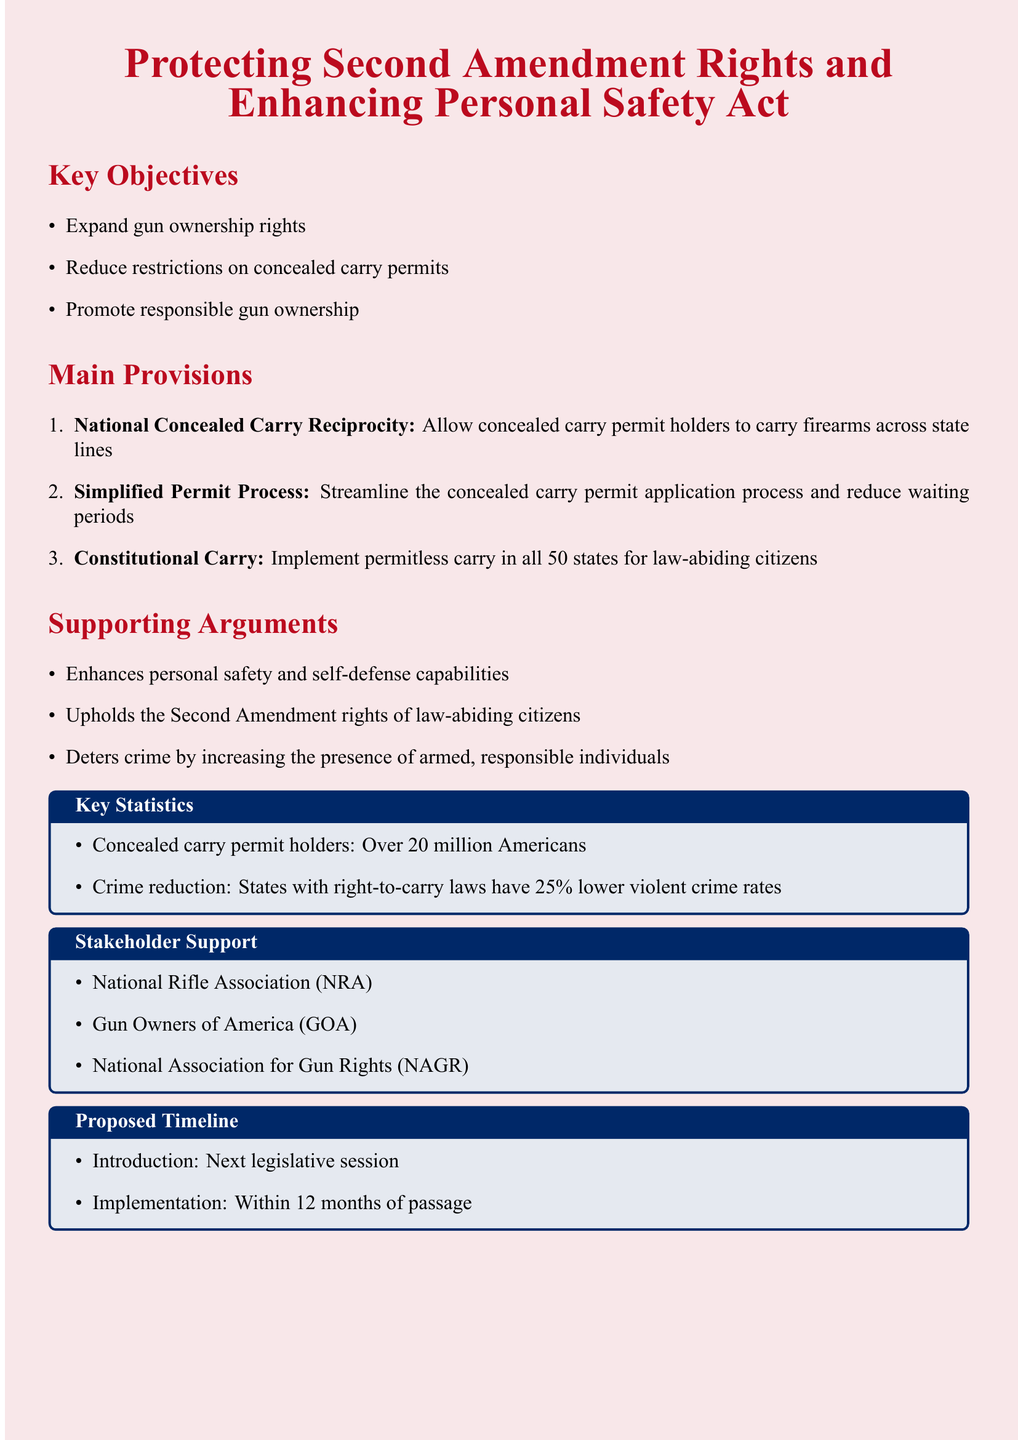What is the title of the legislation? The title of the legislation is found at the beginning of the document and is stated as "Protecting Second Amendment Rights and Enhancing Personal Safety Act."
Answer: Protecting Second Amendment Rights and Enhancing Personal Safety Act How many objectives are listed in the document? The document lists three key objectives related to gun ownership and concealed carry permits.
Answer: 3 Which organization supports the legislation? The document mentions several stakeholders that support the legislation, one of which is the National Rifle Association.
Answer: National Rifle Association (NRA) What is the proposed timeline for implementation? The proposed timeline for implementation is noted in the document, stating it should occur within 12 months of passage.
Answer: 12 months What percentage lower are violent crime rates in states with right-to-carry laws? The document states that violent crime rates are lower by 25 percent in states that have implemented right-to-carry laws.
Answer: 25% What does "Constitutional Carry" refer to in this document? "Constitutional Carry" is defined in the document as permitless carry in all 50 states for law-abiding citizens.
Answer: Permitless carry in all 50 states What is one of the supporting arguments for this legislation? The document lists several supporting arguments, including that it enhances personal safety and self-defense capabilities.
Answer: Enhances personal safety and self-defense capabilities What is the first provision outlined in the main provisions section? The first provision indicated in the document concerns national concealed carry reciprocity, allowing permit holders to carry firearms across state lines.
Answer: National Concealed Carry Reciprocity 